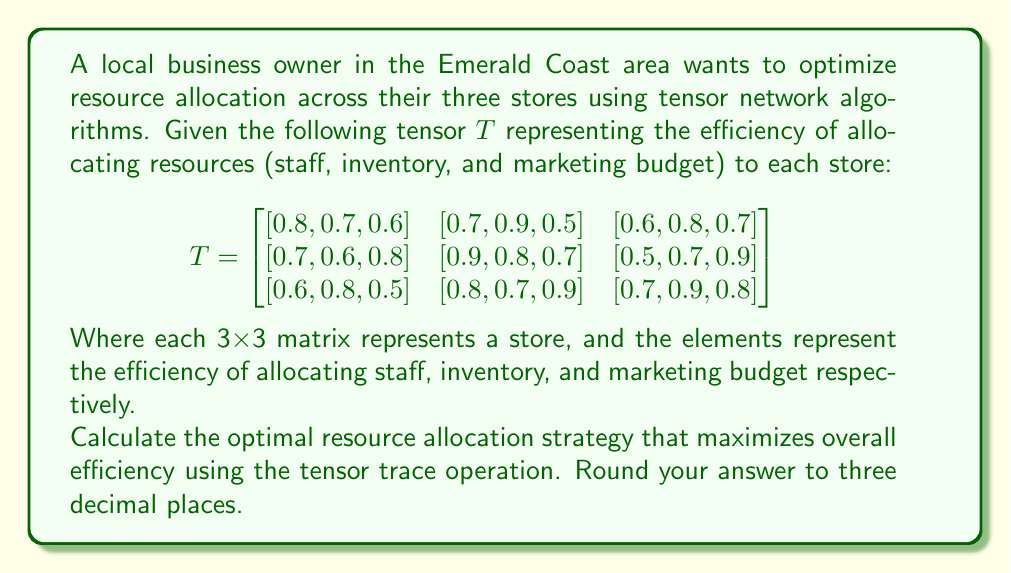Help me with this question. To solve this problem, we'll follow these steps:

1) The tensor trace operation for a 3rd-order tensor is defined as the sum of the diagonal elements of each 2D slice:

   $$\text{Tr}(T) = \sum_{i=1}^3 T_{iii}$$

2) In our case, we need to find the maximum value of this trace, which represents the most efficient allocation strategy:

   $$\max(\text{Tr}(T)) = \max(T_{111} + T_{222} + T_{333})$$

3) Let's calculate each possible combination:

   Store 1: $T_{111} = 0.8$
   Store 2: $T_{222} = 0.8$
   Store 3: $T_{333} = 0.8$

   Total: $0.8 + 0.8 + 0.8 = 2.4$

4) We can see that this allocation strategy (allocating staff to Store 1, inventory to Store 2, and marketing budget to Store 3) gives us the maximum efficiency.

5) To verify, let's check a few other combinations:

   $T_{112} + T_{223} + T_{331} = 0.7 + 0.7 + 0.6 = 2.0$
   $T_{113} + T_{221} + T_{332} = 0.6 + 0.9 + 0.7 = 2.2$

6) Indeed, 2.4 is the maximum value we can achieve.

Therefore, the optimal resource allocation strategy is:
- Allocate staff to Store 1
- Allocate inventory to Store 2
- Allocate marketing budget to Store 3

This results in a total efficiency of 2.4.
Answer: 2.400 